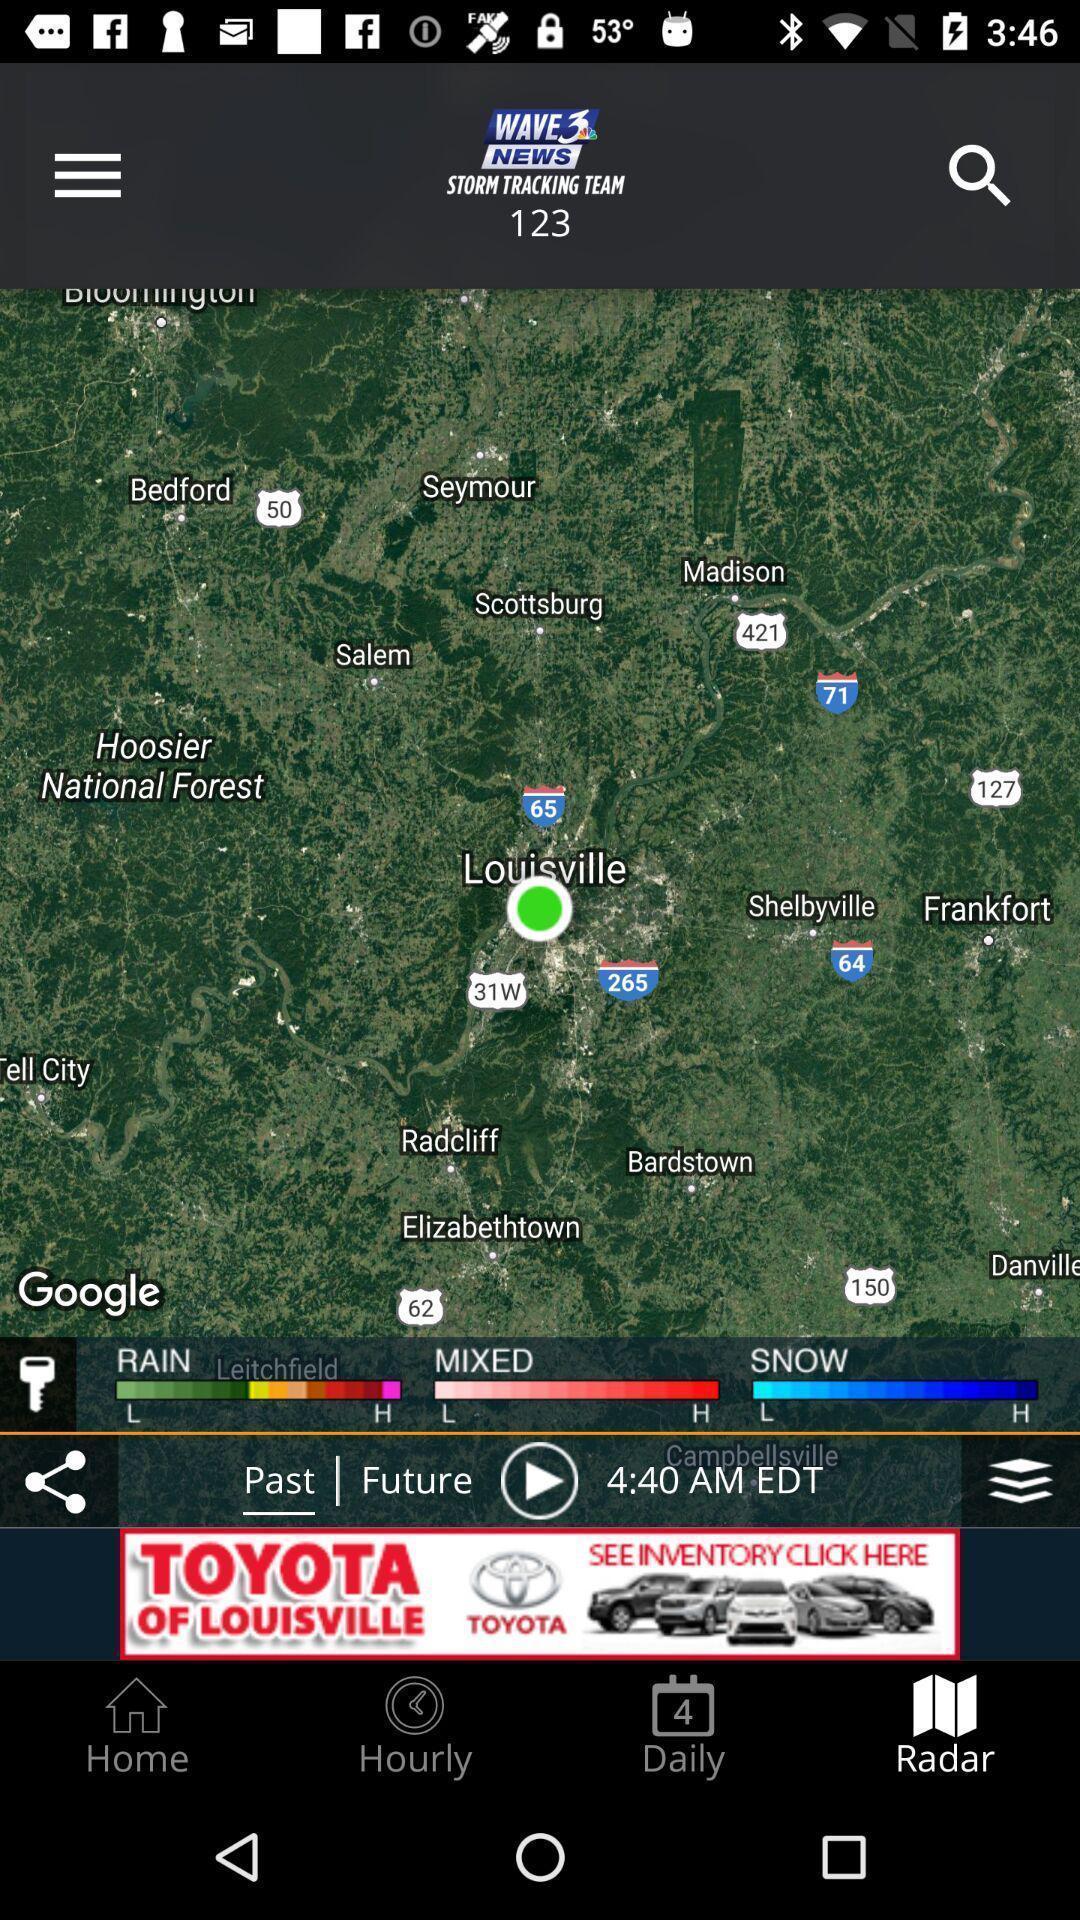Give me a summary of this screen capture. Satellite view of map updating weather report. 